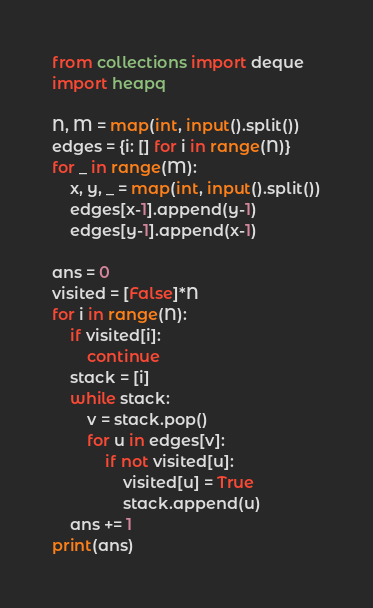<code> <loc_0><loc_0><loc_500><loc_500><_Python_>from collections import deque
import heapq        

N, M = map(int, input().split())
edges = {i: [] for i in range(N)}
for _ in range(M):
    x, y, _ = map(int, input().split())
    edges[x-1].append(y-1)
    edges[y-1].append(x-1)

ans = 0
visited = [False]*N
for i in range(N):
    if visited[i]:
        continue
    stack = [i]
    while stack:
        v = stack.pop()
        for u in edges[v]:
            if not visited[u]:
                visited[u] = True
                stack.append(u)
    ans += 1
print(ans)</code> 